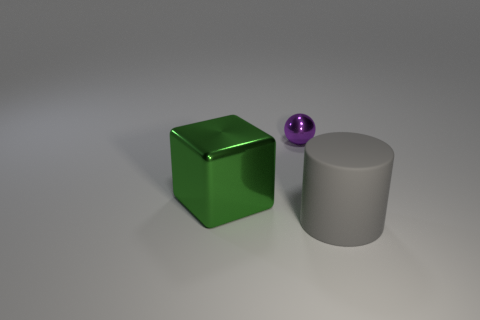Add 2 big green shiny objects. How many objects exist? 5 Subtract all blocks. How many objects are left? 2 Add 2 cubes. How many cubes are left? 3 Add 3 gray matte cylinders. How many gray matte cylinders exist? 4 Subtract 0 brown cylinders. How many objects are left? 3 Subtract all purple shiny objects. Subtract all metal spheres. How many objects are left? 1 